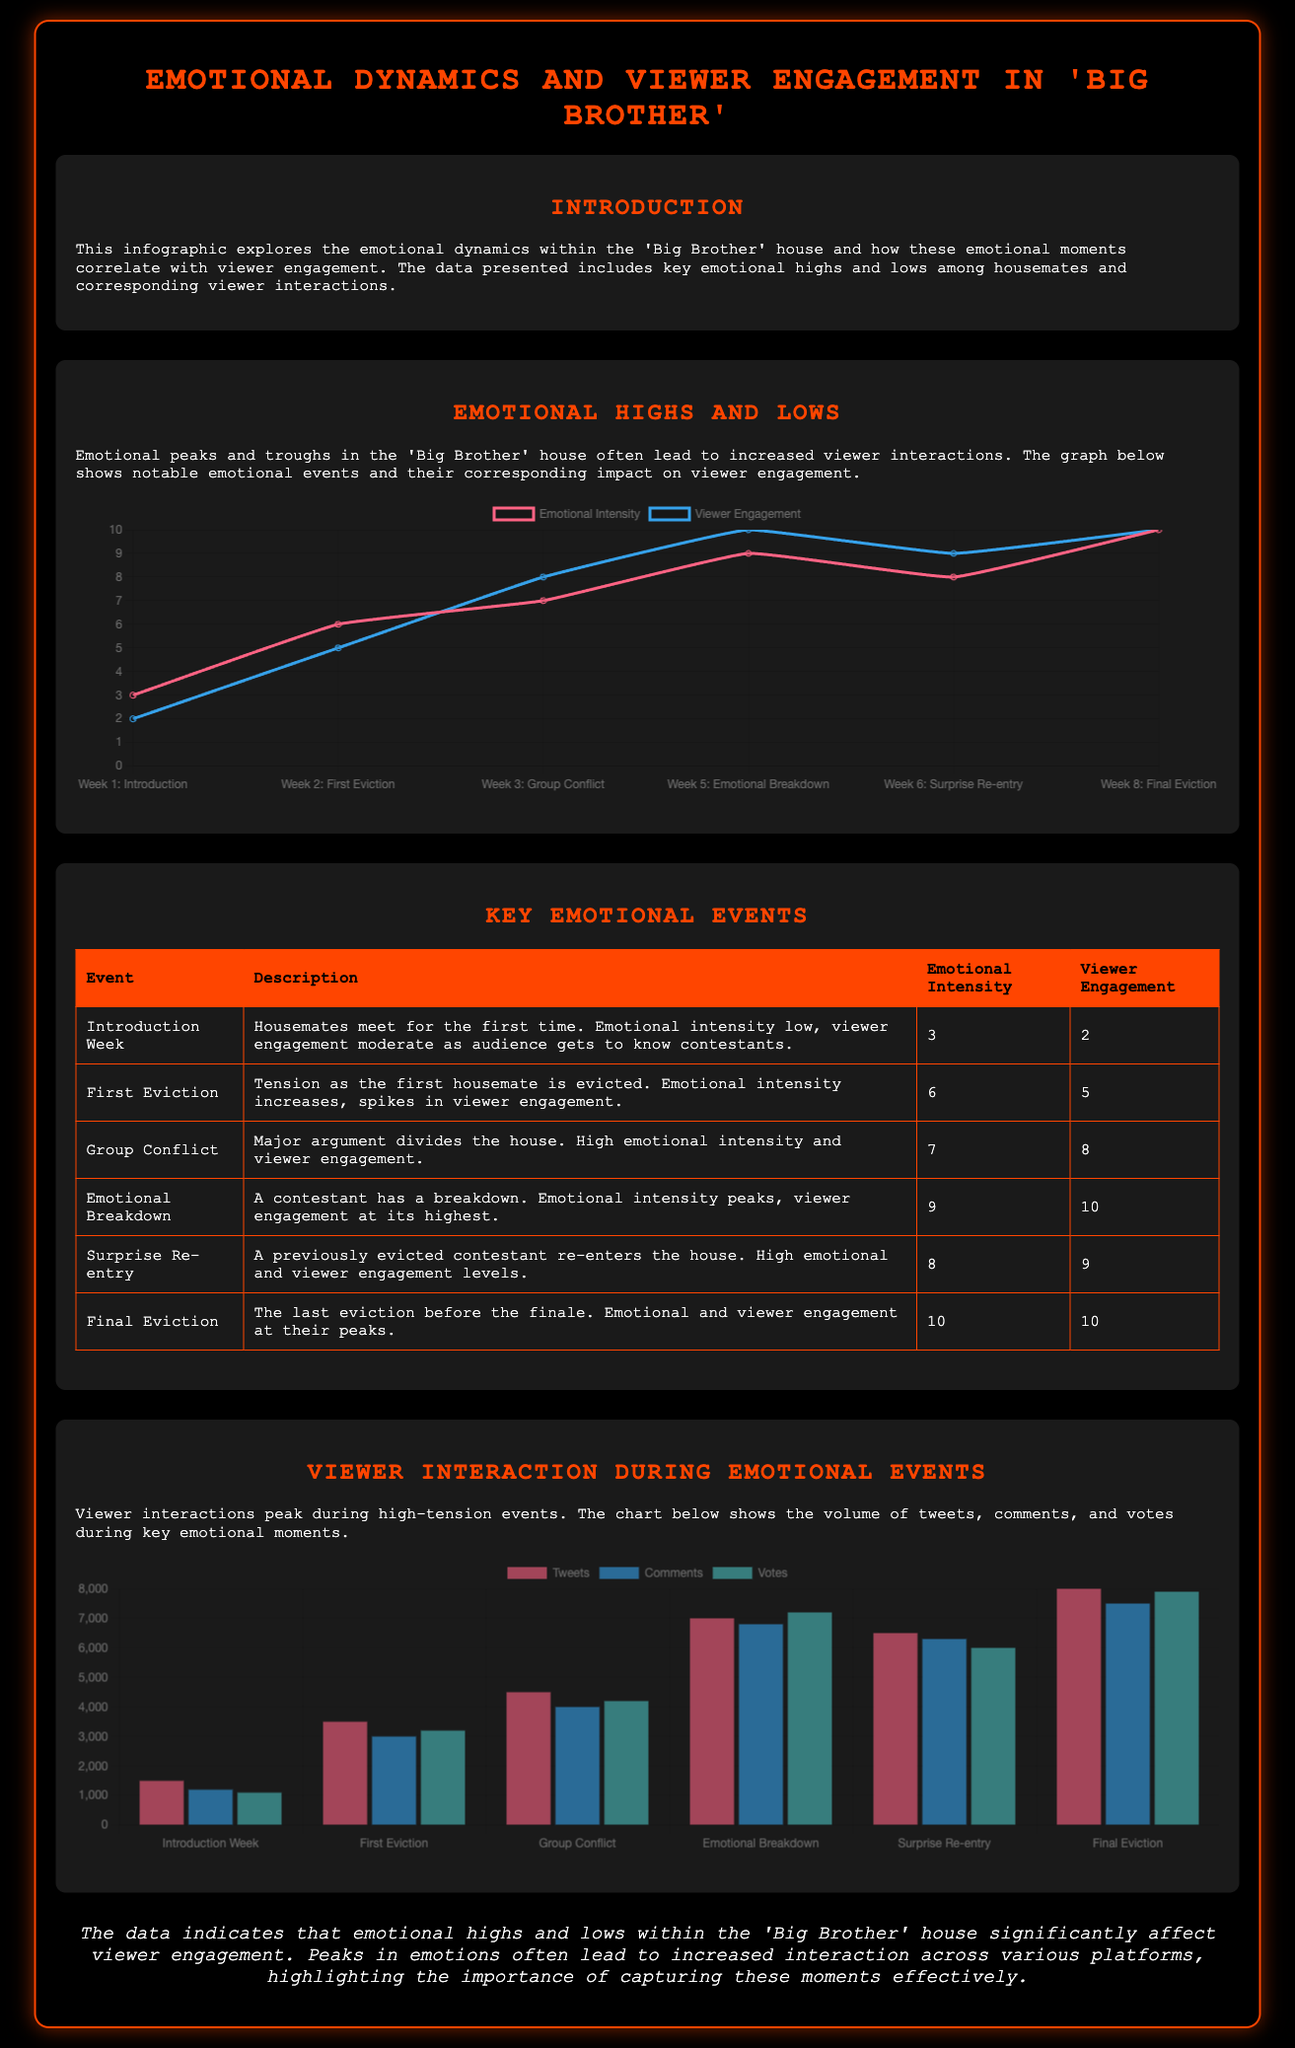What was the emotional intensity during the Emotional Breakdown event? The emotional intensity during the Emotional Breakdown event is listed in the table under "Emotional Intensity."
Answer: 9 What event had the highest viewer engagement? The event with the highest viewer engagement is identified in the table under "Viewer Engagement."
Answer: 10 Which event saw a significant increase in viewer engagement compared to the Introduction Week? The reasoning involves comparing viewer engagement values for both events listed in the table.
Answer: First Eviction How many total tweets were recorded during the Final Eviction event? This is found by looking at the bar chart data for the Final Eviction event.
Answer: 8000 What was the emotional intensity level of the Group Conflict event? This information can be found directly in the table under "Emotional Intensity."
Answer: 7 What is the emotional intensity before the final eviction? The emotional intensity value for the event is listed just before the final eviction.
Answer: 10 Which emotional event corresponds with the highest number of comments? This requires analyzing the bar chart data for each event to find the highest number of comments.
Answer: Emotional Breakdown What pattern is observed regarding emotional events and viewer engagement? The answer derives from analyzing the correlation presented between emotional highs and viewer engagement in the infographic.
Answer: Peaks correlate with increased engagement How many emotional events have an intensity of 7 or higher? This requires counting emotional intensities from the table that are 7 or higher.
Answer: 4 